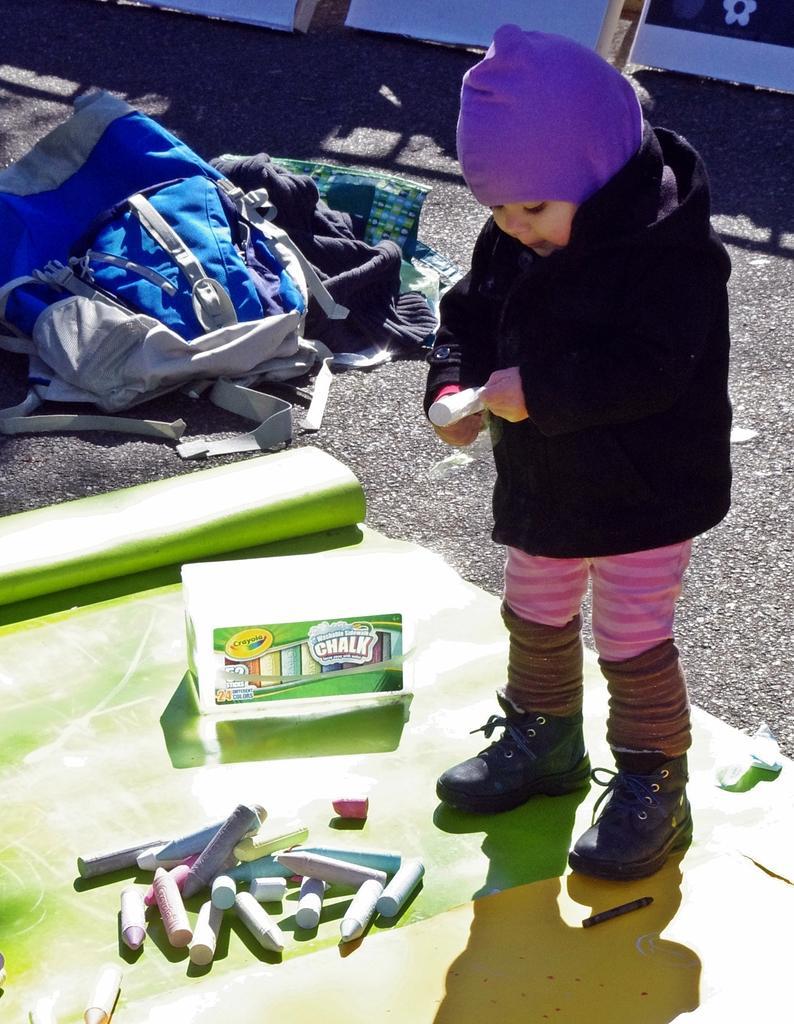In one or two sentences, can you explain what this image depicts? In this image, we can see a kid holding an object is standing. We can see the ground covered with some objects like a bag, some clothes. We can see the mat with some objects. We can also see some white colored objects at the top. 